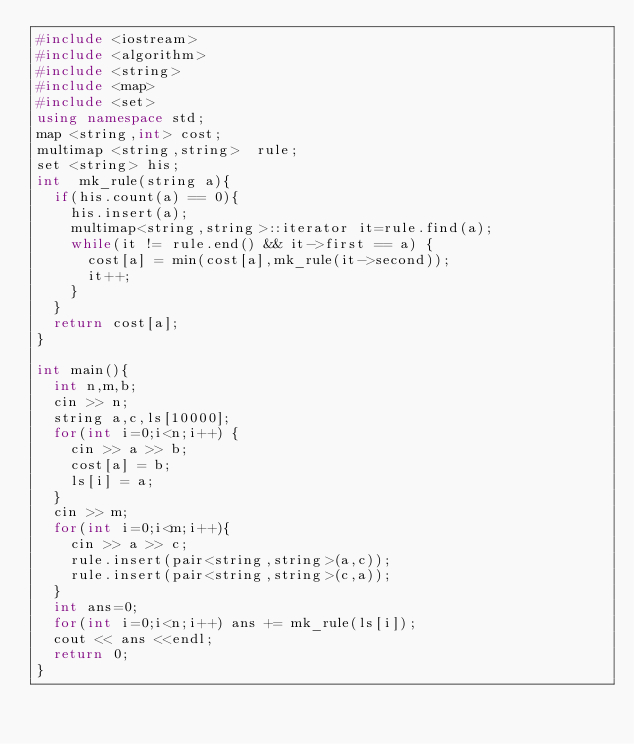<code> <loc_0><loc_0><loc_500><loc_500><_C++_>#include <iostream>
#include <algorithm>
#include <string>
#include <map>
#include <set>
using namespace std;
map <string,int> cost;
multimap <string,string>  rule;
set <string> his;
int  mk_rule(string a){
  if(his.count(a) == 0){
    his.insert(a);
    multimap<string,string>::iterator it=rule.find(a);
    while(it != rule.end() && it->first == a) {
      cost[a] = min(cost[a],mk_rule(it->second));
      it++;
    }
  }
  return cost[a];
}

int main(){
  int n,m,b;
  cin >> n;
  string a,c,ls[10000];
  for(int i=0;i<n;i++) {
    cin >> a >> b;
    cost[a] = b;
    ls[i] = a;
  }
  cin >> m;
  for(int i=0;i<m;i++){
    cin >> a >> c;
    rule.insert(pair<string,string>(a,c));
    rule.insert(pair<string,string>(c,a));
  }
  int ans=0;
  for(int i=0;i<n;i++) ans += mk_rule(ls[i]);
  cout << ans <<endl;
  return 0;
}</code> 